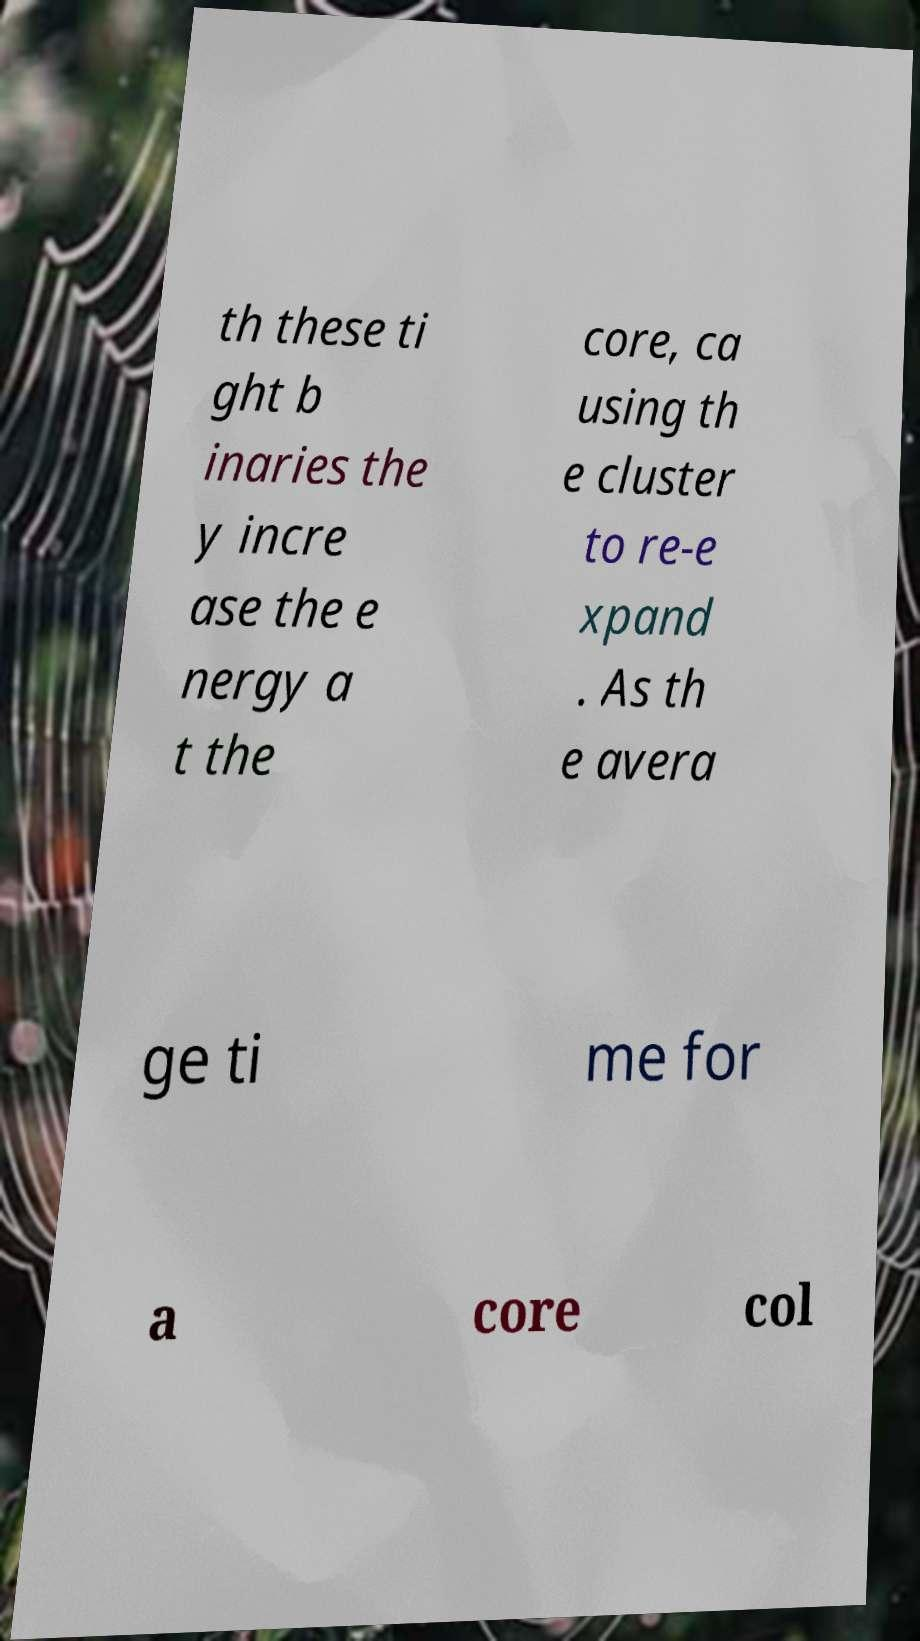Could you extract and type out the text from this image? th these ti ght b inaries the y incre ase the e nergy a t the core, ca using th e cluster to re-e xpand . As th e avera ge ti me for a core col 